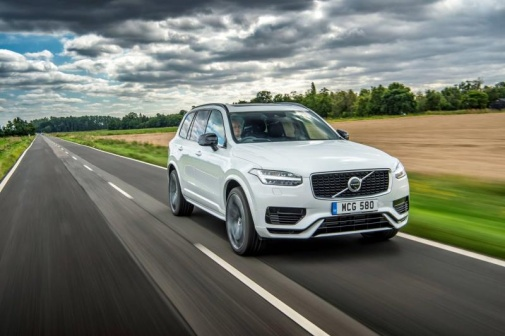Discuss how this image could be part of an advertising campaign. This image could be part of an advertising campaign for Volvo, highlighting the XC90's capabilities and the luxurious driving experience it offers. The serene and picturesque backdrop showcases the vehicle's design in harmony with nature, appealing to those who seek adventure without compromising on comfort and safety. The wet road could emphasize the SUV's superior handling and stability in various weather conditions, reinforcing its reliability. The tagline could be something like 'Volvo XC90: Embrace Every Journey with Confidence,' focusing on themes of exploration, tranquility, and advanced engineering. 